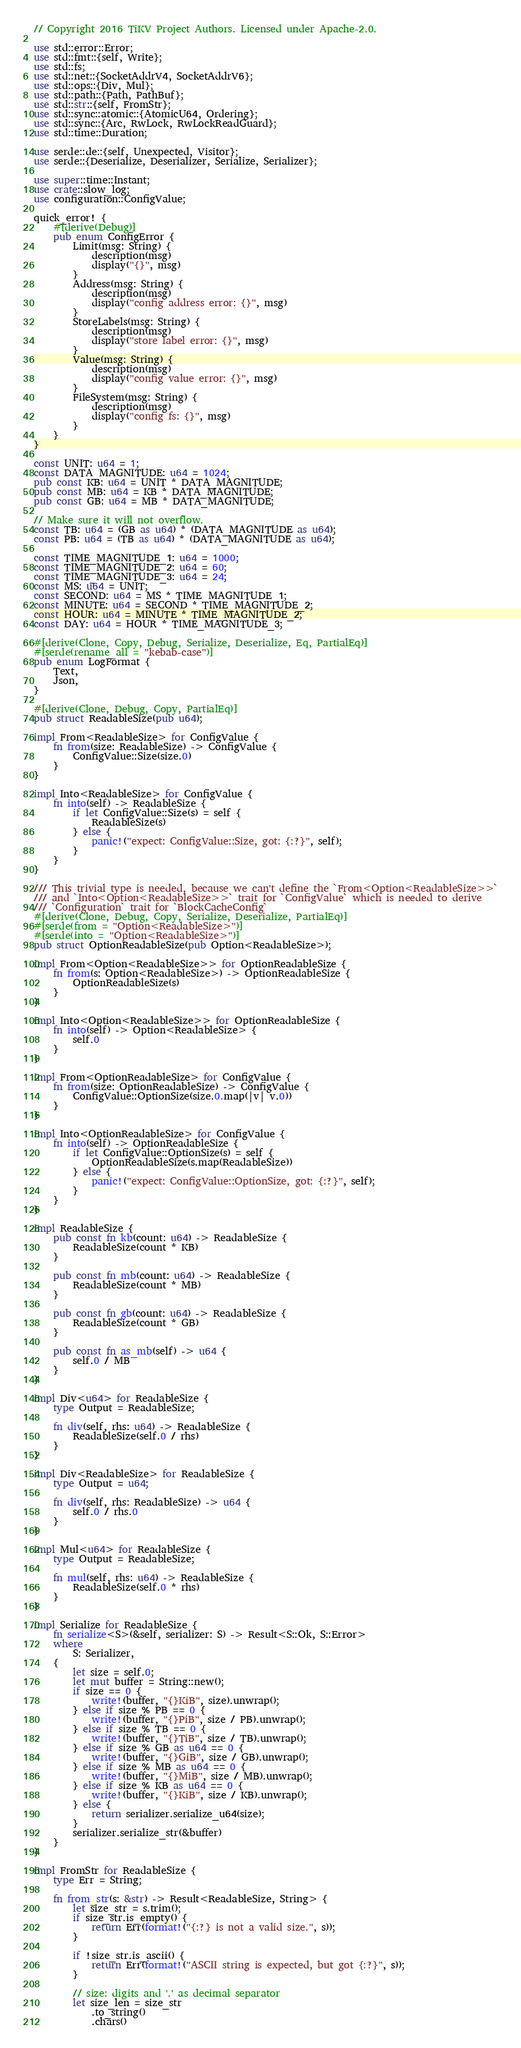<code> <loc_0><loc_0><loc_500><loc_500><_Rust_>// Copyright 2016 TiKV Project Authors. Licensed under Apache-2.0.

use std::error::Error;
use std::fmt::{self, Write};
use std::fs;
use std::net::{SocketAddrV4, SocketAddrV6};
use std::ops::{Div, Mul};
use std::path::{Path, PathBuf};
use std::str::{self, FromStr};
use std::sync::atomic::{AtomicU64, Ordering};
use std::sync::{Arc, RwLock, RwLockReadGuard};
use std::time::Duration;

use serde::de::{self, Unexpected, Visitor};
use serde::{Deserialize, Deserializer, Serialize, Serializer};

use super::time::Instant;
use crate::slow_log;
use configuration::ConfigValue;

quick_error! {
    #[derive(Debug)]
    pub enum ConfigError {
        Limit(msg: String) {
            description(msg)
            display("{}", msg)
        }
        Address(msg: String) {
            description(msg)
            display("config address error: {}", msg)
        }
        StoreLabels(msg: String) {
            description(msg)
            display("store label error: {}", msg)
        }
        Value(msg: String) {
            description(msg)
            display("config value error: {}", msg)
        }
        FileSystem(msg: String) {
            description(msg)
            display("config fs: {}", msg)
        }
    }
}

const UNIT: u64 = 1;
const DATA_MAGNITUDE: u64 = 1024;
pub const KB: u64 = UNIT * DATA_MAGNITUDE;
pub const MB: u64 = KB * DATA_MAGNITUDE;
pub const GB: u64 = MB * DATA_MAGNITUDE;

// Make sure it will not overflow.
const TB: u64 = (GB as u64) * (DATA_MAGNITUDE as u64);
const PB: u64 = (TB as u64) * (DATA_MAGNITUDE as u64);

const TIME_MAGNITUDE_1: u64 = 1000;
const TIME_MAGNITUDE_2: u64 = 60;
const TIME_MAGNITUDE_3: u64 = 24;
const MS: u64 = UNIT;
const SECOND: u64 = MS * TIME_MAGNITUDE_1;
const MINUTE: u64 = SECOND * TIME_MAGNITUDE_2;
const HOUR: u64 = MINUTE * TIME_MAGNITUDE_2;
const DAY: u64 = HOUR * TIME_MAGNITUDE_3;

#[derive(Clone, Copy, Debug, Serialize, Deserialize, Eq, PartialEq)]
#[serde(rename_all = "kebab-case")]
pub enum LogFormat {
    Text,
    Json,
}

#[derive(Clone, Debug, Copy, PartialEq)]
pub struct ReadableSize(pub u64);

impl From<ReadableSize> for ConfigValue {
    fn from(size: ReadableSize) -> ConfigValue {
        ConfigValue::Size(size.0)
    }
}

impl Into<ReadableSize> for ConfigValue {
    fn into(self) -> ReadableSize {
        if let ConfigValue::Size(s) = self {
            ReadableSize(s)
        } else {
            panic!("expect: ConfigValue::Size, got: {:?}", self);
        }
    }
}

/// This trivial type is needed, because we can't define the `From<Option<ReadableSize>>`
/// and `Into<Option<ReadableSize>>` trait for `ConfigValue` which is needed to derive
/// `Configuration` trait for `BlockCacheConfig`
#[derive(Clone, Debug, Copy, Serialize, Deserialize, PartialEq)]
#[serde(from = "Option<ReadableSize>")]
#[serde(into = "Option<ReadableSize>")]
pub struct OptionReadableSize(pub Option<ReadableSize>);

impl From<Option<ReadableSize>> for OptionReadableSize {
    fn from(s: Option<ReadableSize>) -> OptionReadableSize {
        OptionReadableSize(s)
    }
}

impl Into<Option<ReadableSize>> for OptionReadableSize {
    fn into(self) -> Option<ReadableSize> {
        self.0
    }
}

impl From<OptionReadableSize> for ConfigValue {
    fn from(size: OptionReadableSize) -> ConfigValue {
        ConfigValue::OptionSize(size.0.map(|v| v.0))
    }
}

impl Into<OptionReadableSize> for ConfigValue {
    fn into(self) -> OptionReadableSize {
        if let ConfigValue::OptionSize(s) = self {
            OptionReadableSize(s.map(ReadableSize))
        } else {
            panic!("expect: ConfigValue::OptionSize, got: {:?}", self);
        }
    }
}

impl ReadableSize {
    pub const fn kb(count: u64) -> ReadableSize {
        ReadableSize(count * KB)
    }

    pub const fn mb(count: u64) -> ReadableSize {
        ReadableSize(count * MB)
    }

    pub const fn gb(count: u64) -> ReadableSize {
        ReadableSize(count * GB)
    }

    pub const fn as_mb(self) -> u64 {
        self.0 / MB
    }
}

impl Div<u64> for ReadableSize {
    type Output = ReadableSize;

    fn div(self, rhs: u64) -> ReadableSize {
        ReadableSize(self.0 / rhs)
    }
}

impl Div<ReadableSize> for ReadableSize {
    type Output = u64;

    fn div(self, rhs: ReadableSize) -> u64 {
        self.0 / rhs.0
    }
}

impl Mul<u64> for ReadableSize {
    type Output = ReadableSize;

    fn mul(self, rhs: u64) -> ReadableSize {
        ReadableSize(self.0 * rhs)
    }
}

impl Serialize for ReadableSize {
    fn serialize<S>(&self, serializer: S) -> Result<S::Ok, S::Error>
    where
        S: Serializer,
    {
        let size = self.0;
        let mut buffer = String::new();
        if size == 0 {
            write!(buffer, "{}KiB", size).unwrap();
        } else if size % PB == 0 {
            write!(buffer, "{}PiB", size / PB).unwrap();
        } else if size % TB == 0 {
            write!(buffer, "{}TiB", size / TB).unwrap();
        } else if size % GB as u64 == 0 {
            write!(buffer, "{}GiB", size / GB).unwrap();
        } else if size % MB as u64 == 0 {
            write!(buffer, "{}MiB", size / MB).unwrap();
        } else if size % KB as u64 == 0 {
            write!(buffer, "{}KiB", size / KB).unwrap();
        } else {
            return serializer.serialize_u64(size);
        }
        serializer.serialize_str(&buffer)
    }
}

impl FromStr for ReadableSize {
    type Err = String;

    fn from_str(s: &str) -> Result<ReadableSize, String> {
        let size_str = s.trim();
        if size_str.is_empty() {
            return Err(format!("{:?} is not a valid size.", s));
        }

        if !size_str.is_ascii() {
            return Err(format!("ASCII string is expected, but got {:?}", s));
        }

        // size: digits and '.' as decimal separator
        let size_len = size_str
            .to_string()
            .chars()</code> 